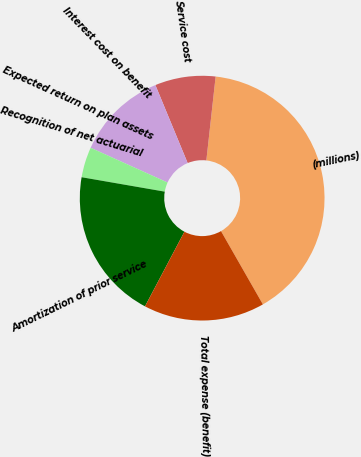Convert chart to OTSL. <chart><loc_0><loc_0><loc_500><loc_500><pie_chart><fcel>(millions)<fcel>Service cost<fcel>Interest cost on benefit<fcel>Expected return on plan assets<fcel>Recognition of net actuarial<fcel>Amortization of prior service<fcel>Total expense (benefit)<nl><fcel>39.98%<fcel>8.0%<fcel>12.0%<fcel>0.01%<fcel>4.01%<fcel>20.0%<fcel>16.0%<nl></chart> 